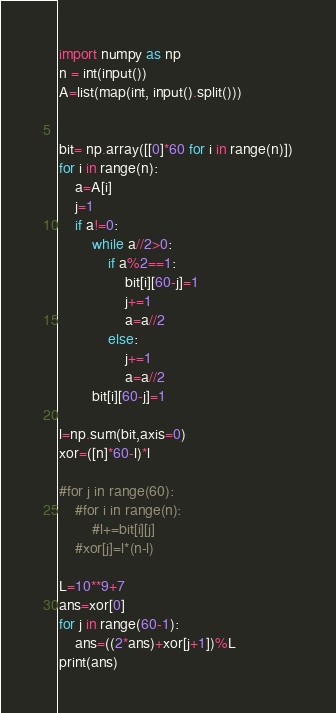<code> <loc_0><loc_0><loc_500><loc_500><_Python_>import numpy as np
n = int(input())
A=list(map(int, input().split()))


bit= np.array([[0]*60 for i in range(n)])
for i in range(n):
    a=A[i]
    j=1
    if a!=0:    
        while a//2>0:
            if a%2==1:
                bit[i][60-j]=1
                j+=1
                a=a//2
            else:
                j+=1
                a=a//2
        bit[i][60-j]=1
           
l=np.sum(bit,axis=0)           
xor=([n]*60-l)*l
    
#for j in range(60):
    #for i in range(n):
        #l+=bit[i][j]
    #xor[j]=l*(n-l)
    
L=10**9+7
ans=xor[0]
for j in range(60-1):
    ans=((2*ans)+xor[j+1])%L
print(ans)    </code> 